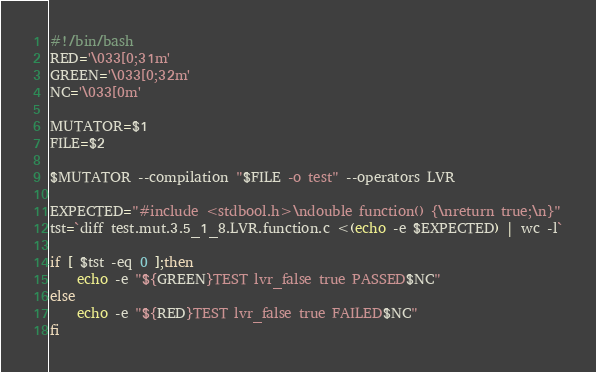<code> <loc_0><loc_0><loc_500><loc_500><_Bash_>#!/bin/bash
RED='\033[0;31m'
GREEN='\033[0;32m'
NC='\033[0m'

MUTATOR=$1
FILE=$2

$MUTATOR --compilation "$FILE -o test" --operators LVR

EXPECTED="#include <stdbool.h>\ndouble function() {\nreturn true;\n}"
tst=`diff test.mut.3.5_1_8.LVR.function.c <(echo -e $EXPECTED) | wc -l`

if [ $tst -eq 0 ];then
    echo -e "${GREEN}TEST lvr_false true PASSED$NC"
else
    echo -e "${RED}TEST lvr_false true FAILED$NC"
fi
</code> 